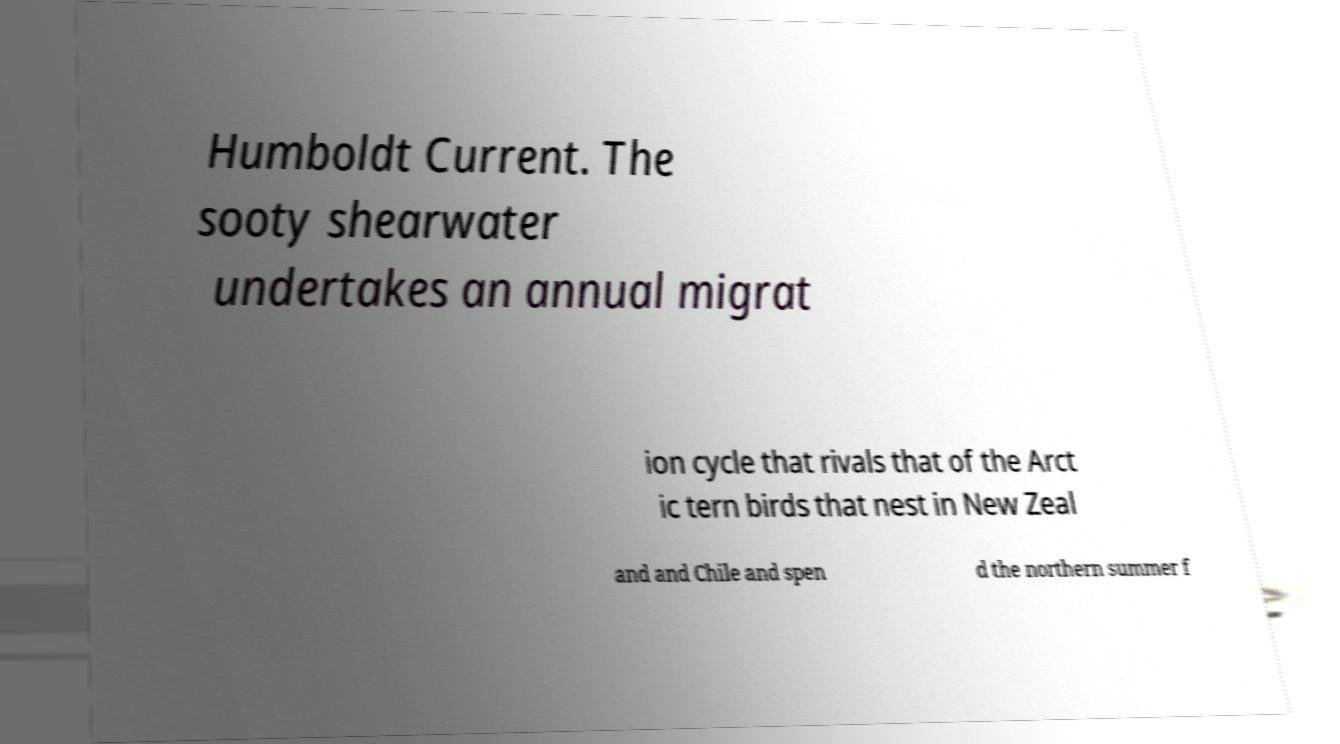Please identify and transcribe the text found in this image. Humboldt Current. The sooty shearwater undertakes an annual migrat ion cycle that rivals that of the Arct ic tern birds that nest in New Zeal and and Chile and spen d the northern summer f 